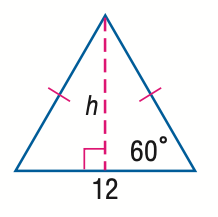Answer the mathemtical geometry problem and directly provide the correct option letter.
Question: Find h in the triangle.
Choices: A: 3 \sqrt 3 B: 6 C: 6 \sqrt 2 D: 6 \sqrt 3 D 